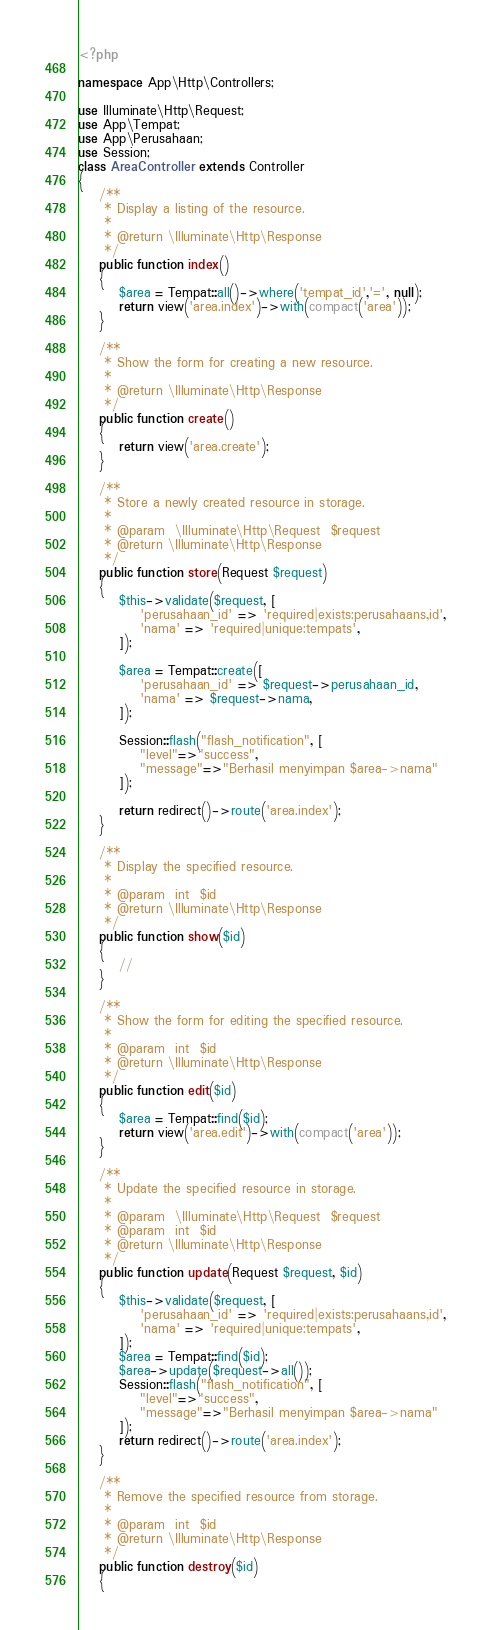Convert code to text. <code><loc_0><loc_0><loc_500><loc_500><_PHP_><?php

namespace App\Http\Controllers;

use Illuminate\Http\Request;
use App\Tempat;
use App\Perusahaan;
use Session;
class AreaController extends Controller
{
    /**
     * Display a listing of the resource.
     *
     * @return \Illuminate\Http\Response
     */
    public function index()
    {
        $area = Tempat::all()->where('tempat_id','=', null);
        return view('area.index')->with(compact('area'));
    }

    /**
     * Show the form for creating a new resource.
     *
     * @return \Illuminate\Http\Response
     */
    public function create()
    {
        return view('area.create');
    }

    /**
     * Store a newly created resource in storage.
     *
     * @param  \Illuminate\Http\Request  $request
     * @return \Illuminate\Http\Response
     */
    public function store(Request $request)
    {
        $this->validate($request, [
            'perusahaan_id' => 'required|exists:perusahaans,id',
            'nama' => 'required|unique:tempats',
        ]);

        $area = Tempat::create([
            'perusahaan_id' => $request->perusahaan_id,
            'nama' => $request->nama,
        ]);

        Session::flash("flash_notification", [
            "level"=>"success",
            "message"=>"Berhasil menyimpan $area->nama"
        ]);

        return redirect()->route('area.index');
    }

    /**
     * Display the specified resource.
     *
     * @param  int  $id
     * @return \Illuminate\Http\Response
     */
    public function show($id)
    {
        //
    }

    /**
     * Show the form for editing the specified resource.
     *
     * @param  int  $id
     * @return \Illuminate\Http\Response
     */
    public function edit($id)
    {
        $area = Tempat::find($id);
        return view('area.edit')->with(compact('area'));
    }

    /**
     * Update the specified resource in storage.
     *
     * @param  \Illuminate\Http\Request  $request
     * @param  int  $id
     * @return \Illuminate\Http\Response
     */
    public function update(Request $request, $id)
    {
        $this->validate($request, [
            'perusahaan_id' => 'required|exists:perusahaans,id',
            'nama' => 'required|unique:tempats',
        ]);
        $area = Tempat::find($id);
        $area->update($request->all());
        Session::flash("flash_notification", [
            "level"=>"success",
            "message"=>"Berhasil menyimpan $area->nama"
        ]);
        return redirect()->route('area.index');
    }

    /**
     * Remove the specified resource from storage.
     *
     * @param  int  $id
     * @return \Illuminate\Http\Response
     */
    public function destroy($id)
    {</code> 